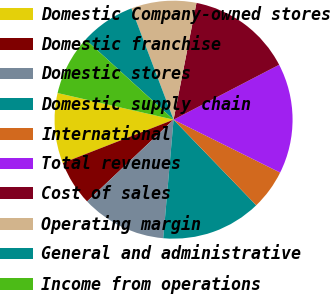Convert chart. <chart><loc_0><loc_0><loc_500><loc_500><pie_chart><fcel>Domestic Company-owned stores<fcel>Domestic franchise<fcel>Domestic stores<fcel>Domestic supply chain<fcel>International<fcel>Total revenues<fcel>Cost of sales<fcel>Operating margin<fcel>General and administrative<fcel>Income from operations<nl><fcel>9.52%<fcel>6.12%<fcel>11.56%<fcel>13.6%<fcel>5.44%<fcel>14.96%<fcel>14.28%<fcel>8.84%<fcel>7.48%<fcel>8.16%<nl></chart> 